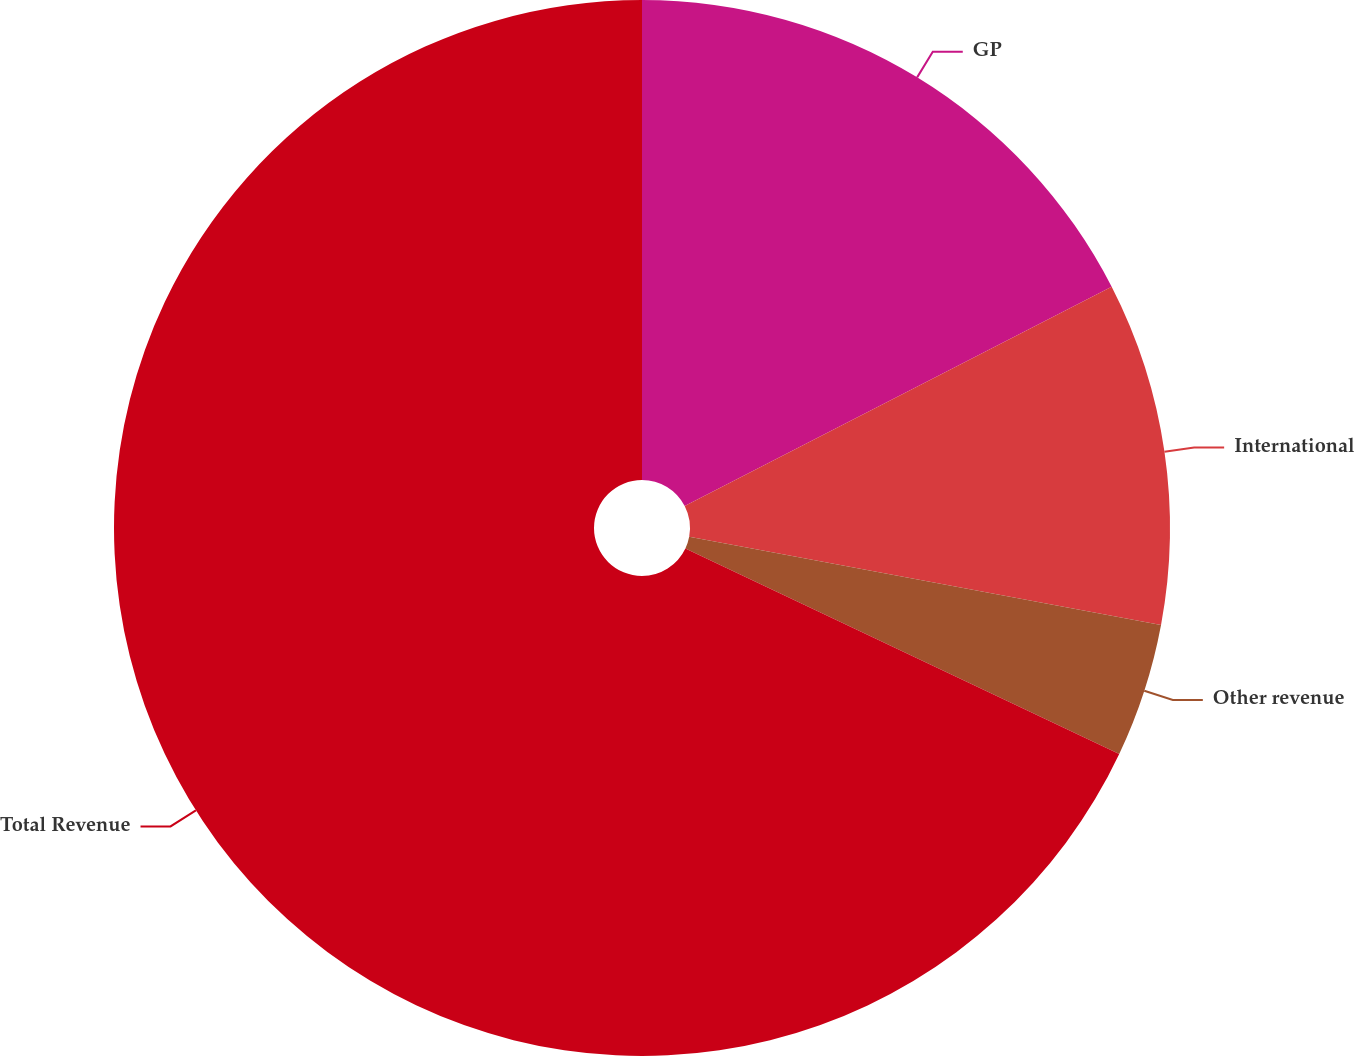<chart> <loc_0><loc_0><loc_500><loc_500><pie_chart><fcel>GP<fcel>International<fcel>Other revenue<fcel>Total Revenue<nl><fcel>17.45%<fcel>10.49%<fcel>4.1%<fcel>67.97%<nl></chart> 